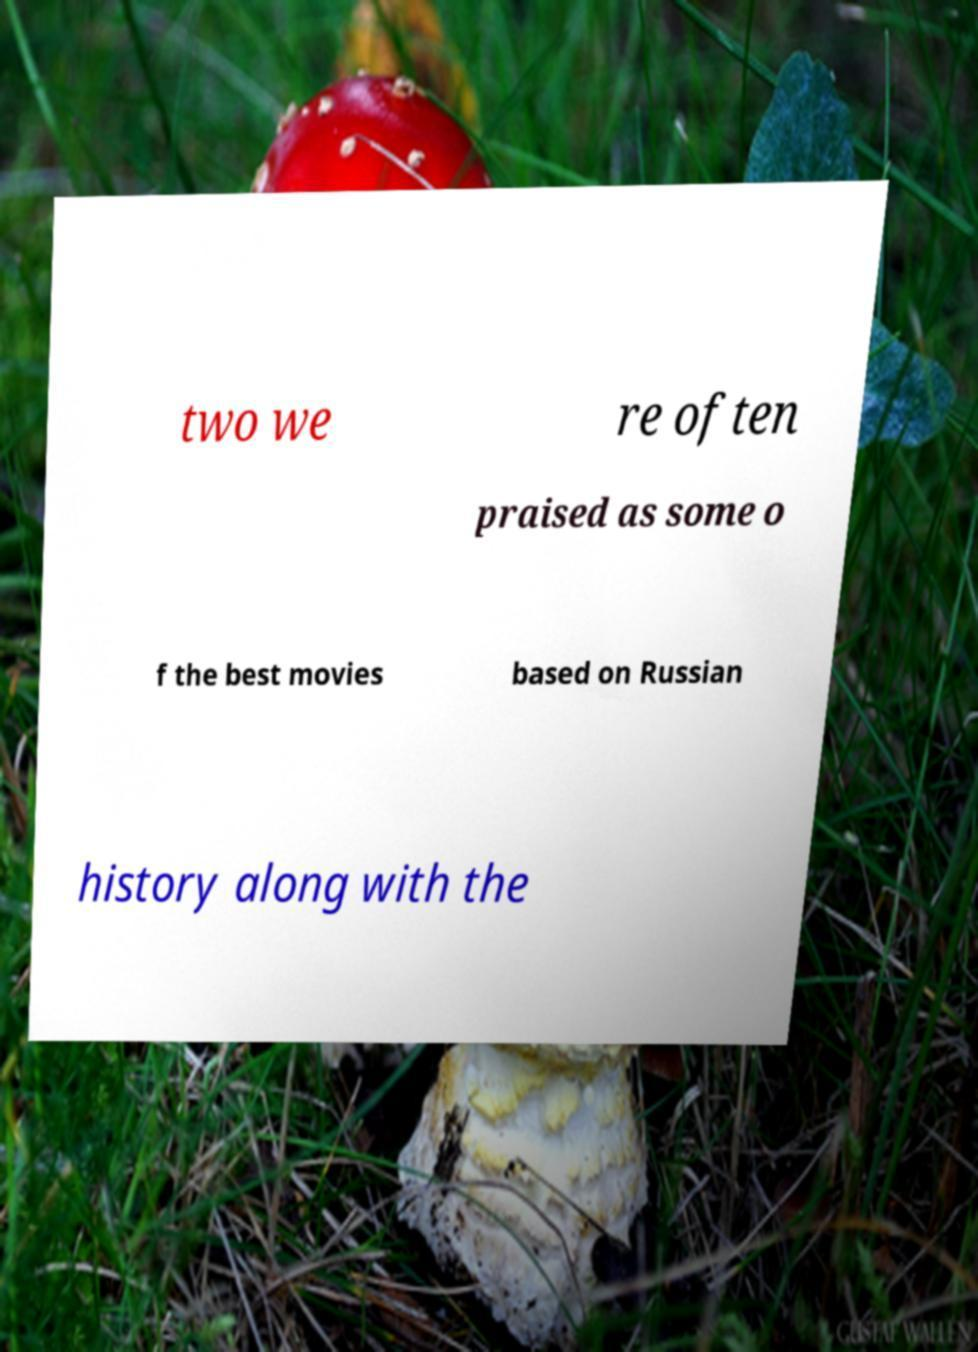What messages or text are displayed in this image? I need them in a readable, typed format. two we re often praised as some o f the best movies based on Russian history along with the 